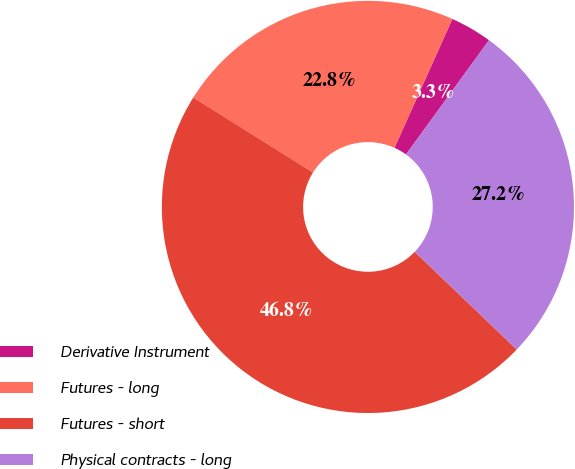Convert chart. <chart><loc_0><loc_0><loc_500><loc_500><pie_chart><fcel>Derivative Instrument<fcel>Futures - long<fcel>Futures - short<fcel>Physical contracts - long<nl><fcel>3.28%<fcel>22.81%<fcel>46.75%<fcel>27.16%<nl></chart> 